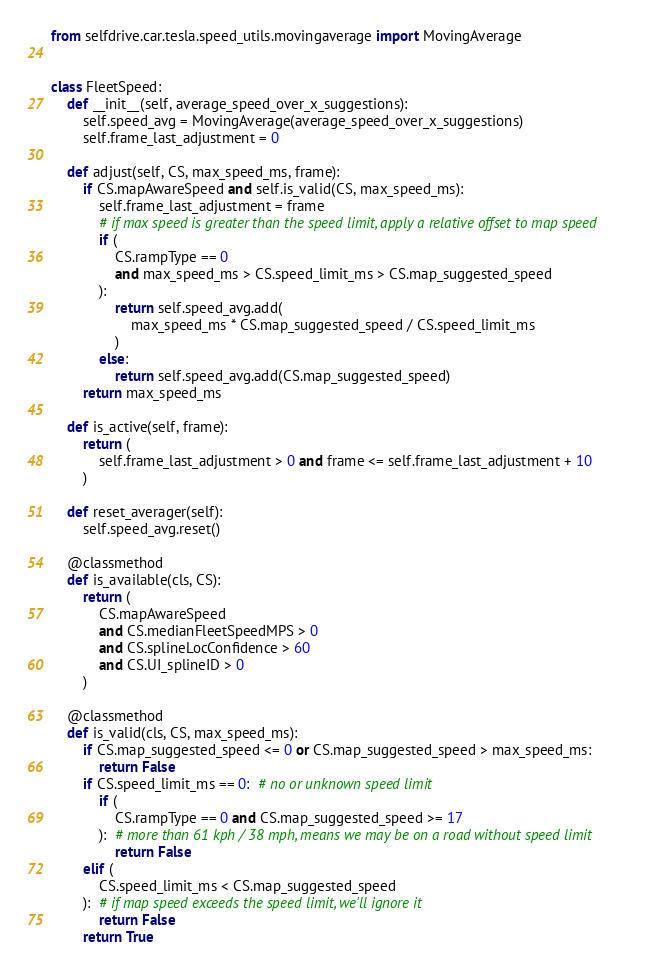<code> <loc_0><loc_0><loc_500><loc_500><_Python_>from selfdrive.car.tesla.speed_utils.movingaverage import MovingAverage


class FleetSpeed:
    def __init__(self, average_speed_over_x_suggestions):
        self.speed_avg = MovingAverage(average_speed_over_x_suggestions)
        self.frame_last_adjustment = 0

    def adjust(self, CS, max_speed_ms, frame):
        if CS.mapAwareSpeed and self.is_valid(CS, max_speed_ms):
            self.frame_last_adjustment = frame
            # if max speed is greater than the speed limit, apply a relative offset to map speed
            if (
                CS.rampType == 0
                and max_speed_ms > CS.speed_limit_ms > CS.map_suggested_speed
            ):
                return self.speed_avg.add(
                    max_speed_ms * CS.map_suggested_speed / CS.speed_limit_ms
                )
            else:
                return self.speed_avg.add(CS.map_suggested_speed)
        return max_speed_ms

    def is_active(self, frame):
        return (
            self.frame_last_adjustment > 0 and frame <= self.frame_last_adjustment + 10
        )

    def reset_averager(self):
        self.speed_avg.reset()

    @classmethod
    def is_available(cls, CS):
        return (
            CS.mapAwareSpeed
            and CS.medianFleetSpeedMPS > 0
            and CS.splineLocConfidence > 60
            and CS.UI_splineID > 0
        )

    @classmethod
    def is_valid(cls, CS, max_speed_ms):
        if CS.map_suggested_speed <= 0 or CS.map_suggested_speed > max_speed_ms:
            return False
        if CS.speed_limit_ms == 0:  # no or unknown speed limit
            if (
                CS.rampType == 0 and CS.map_suggested_speed >= 17
            ):  # more than 61 kph / 38 mph, means we may be on a road without speed limit
                return False
        elif (
            CS.speed_limit_ms < CS.map_suggested_speed
        ):  # if map speed exceeds the speed limit, we'll ignore it
            return False
        return True</code> 